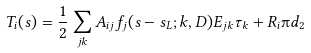Convert formula to latex. <formula><loc_0><loc_0><loc_500><loc_500>T _ { i } ( s ) = \frac { 1 } { 2 } \sum _ { j k } A _ { i j } f _ { j } ( s - s _ { L } ; k , D ) E _ { j k } \tau _ { k } + R _ { i } \i d _ { 2 }</formula> 